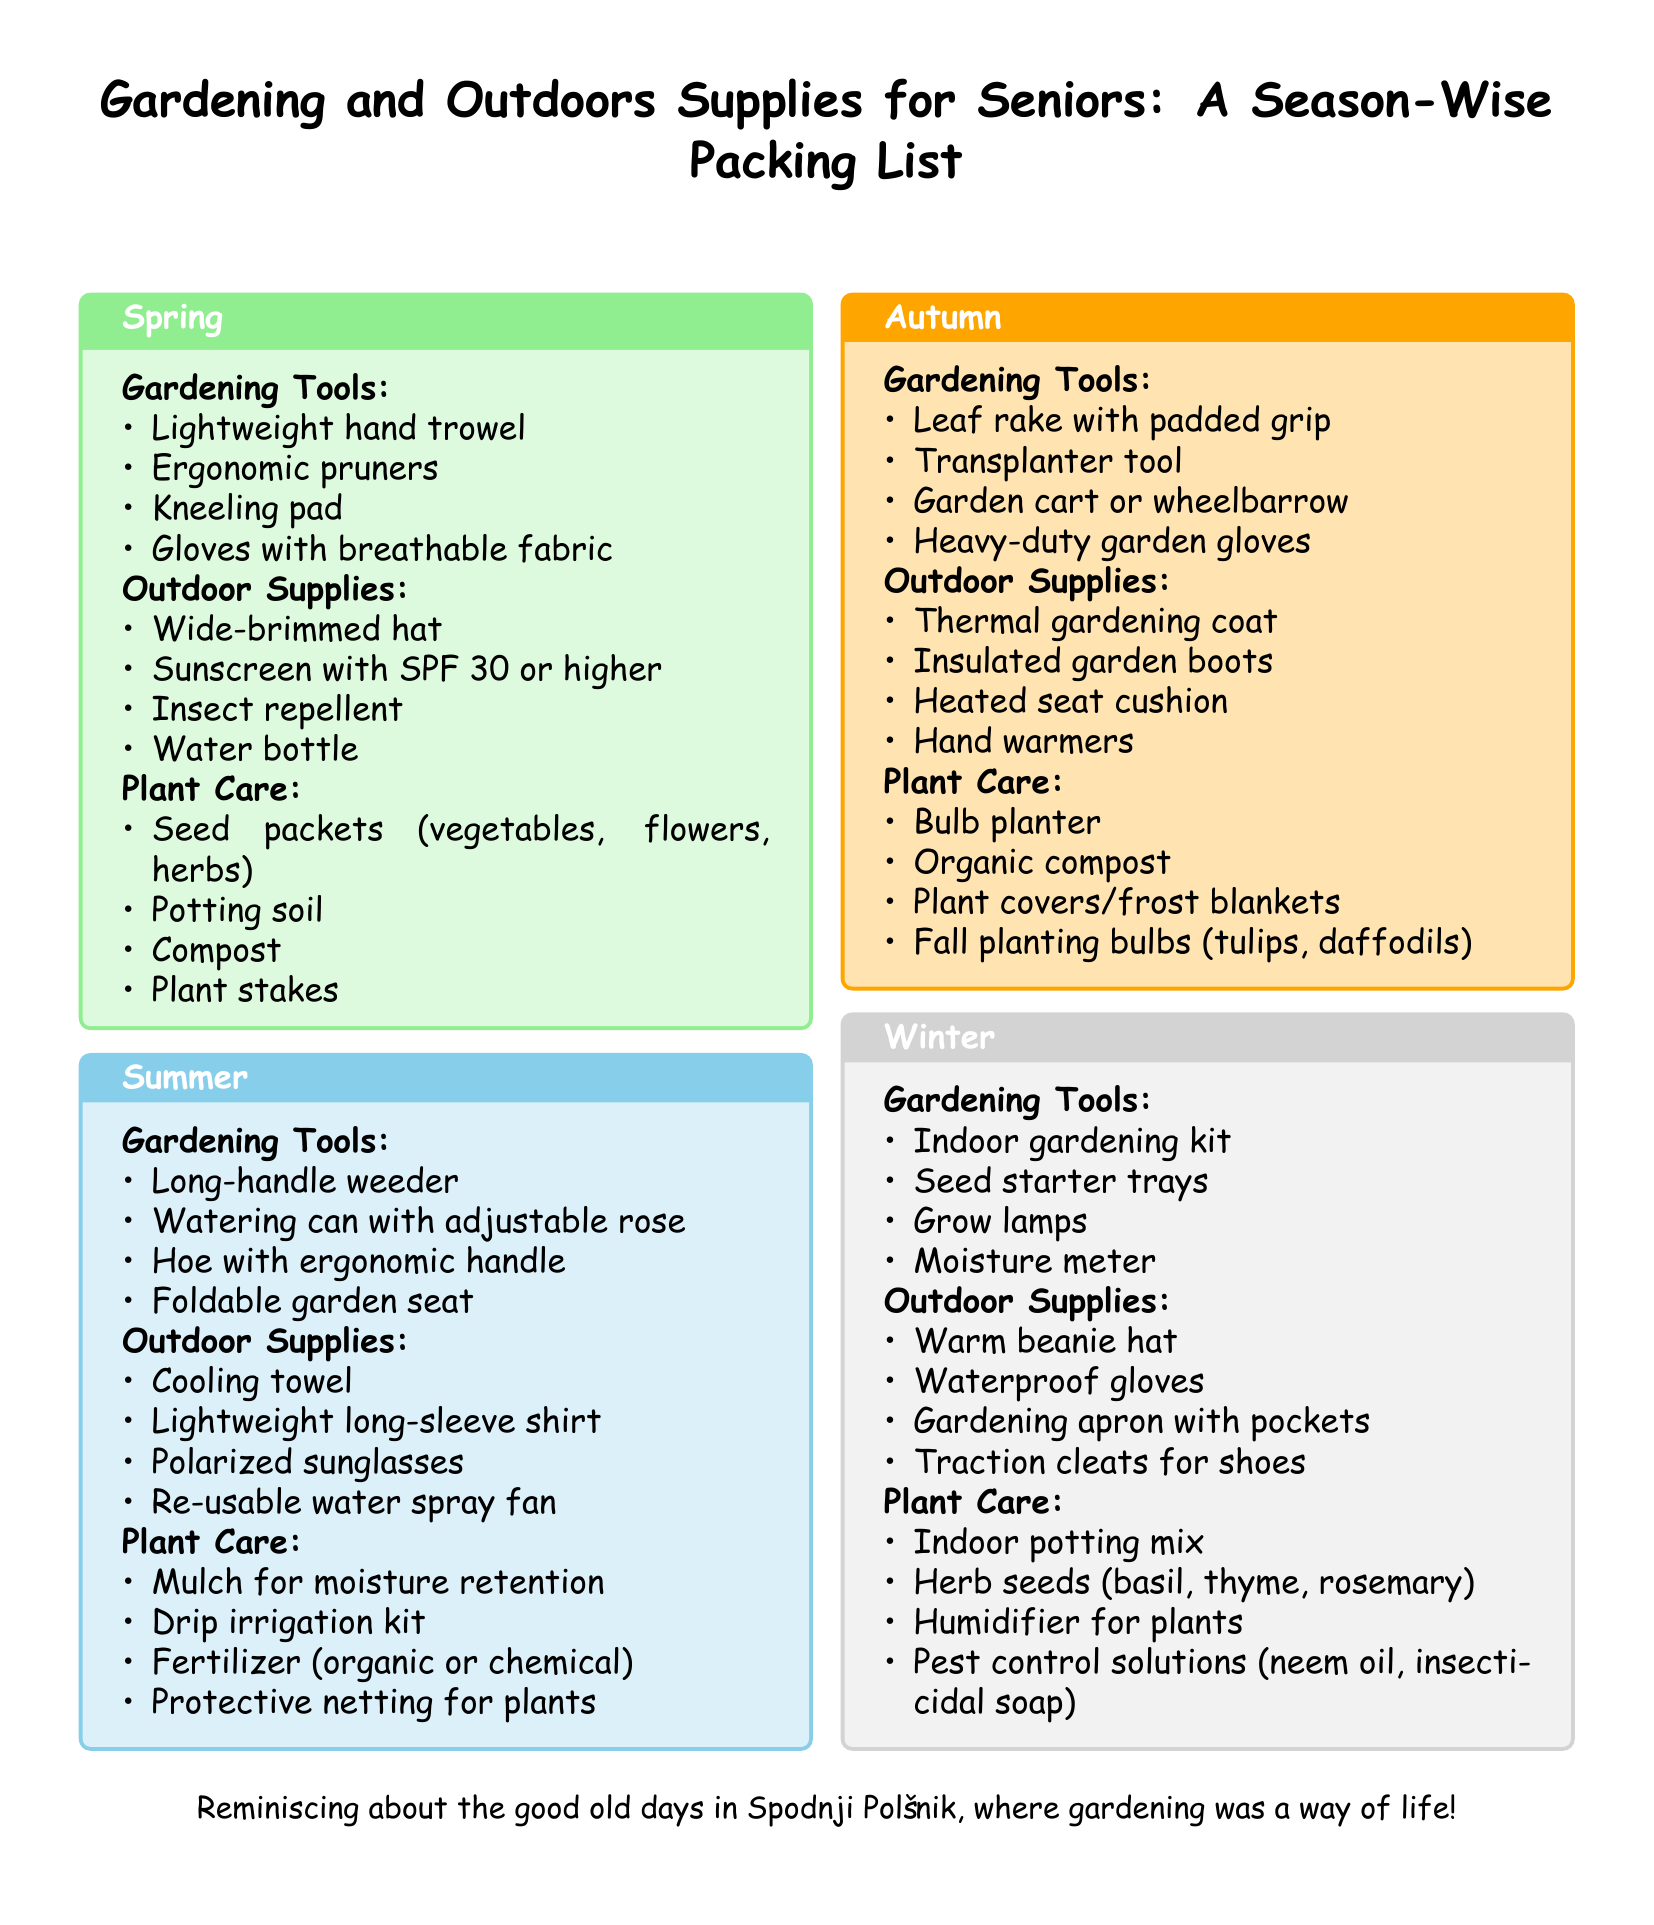What gardening tool is suggested for spring? The document lists a lightweight hand trowel as a gardening tool suggested for spring.
Answer: Lightweight hand trowel What is a recommended outdoor supply for summer? The document mentions a cooling towel as a recommended outdoor supply for summer.
Answer: Cooling towel How many types of gardening tools are listed for autumn? The document indicates there are four types of gardening tools listed for autumn.
Answer: 4 What is included in plant care for winter? The document includes an indoor potting mix in the plant care section for winter.
Answer: Indoor potting mix Which season suggests the use of a kneeling pad? The document states that a kneeling pad is suggested for spring gardening activities.
Answer: Spring What type of seeds are suggested for plant care in winter? The document specifies herb seeds such as basil, thyme, and rosemary for winter plant care.
Answer: Herb seeds What does the autumn section recommend for thermal protection? The document recommends a thermal gardening coat for thermal protection in autumn.
Answer: Thermal gardening coat How many outdoor supplies are listed for summer? The document lists four outdoor supplies for summer.
Answer: 4 What gardening tool is mentioned for indoor gardening in winter? An indoor gardening kit is mentioned as a gardening tool for winter.
Answer: Indoor gardening kit 